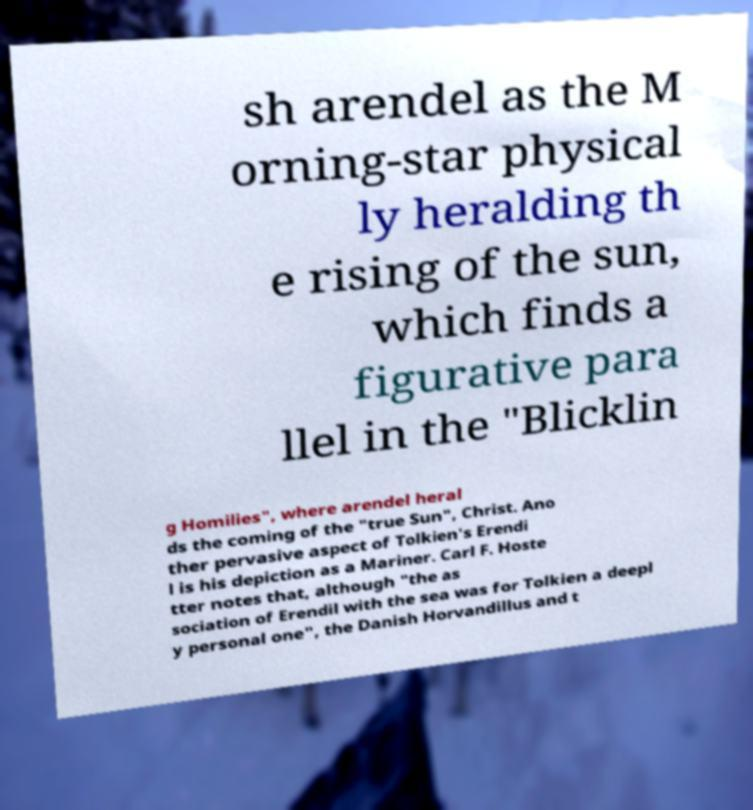Could you extract and type out the text from this image? sh arendel as the M orning-star physical ly heralding th e rising of the sun, which finds a figurative para llel in the "Blicklin g Homilies", where arendel heral ds the coming of the "true Sun", Christ. Ano ther pervasive aspect of Tolkien's Erendi l is his depiction as a Mariner. Carl F. Hoste tter notes that, although "the as sociation of Erendil with the sea was for Tolkien a deepl y personal one", the Danish Horvandillus and t 